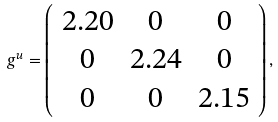<formula> <loc_0><loc_0><loc_500><loc_500>g ^ { u } = \left ( \begin{array} { c c c } 2 . 2 0 & 0 & 0 \\ 0 & 2 . 2 4 & 0 \\ 0 & 0 & 2 . 1 5 \end{array} \right ) ,</formula> 